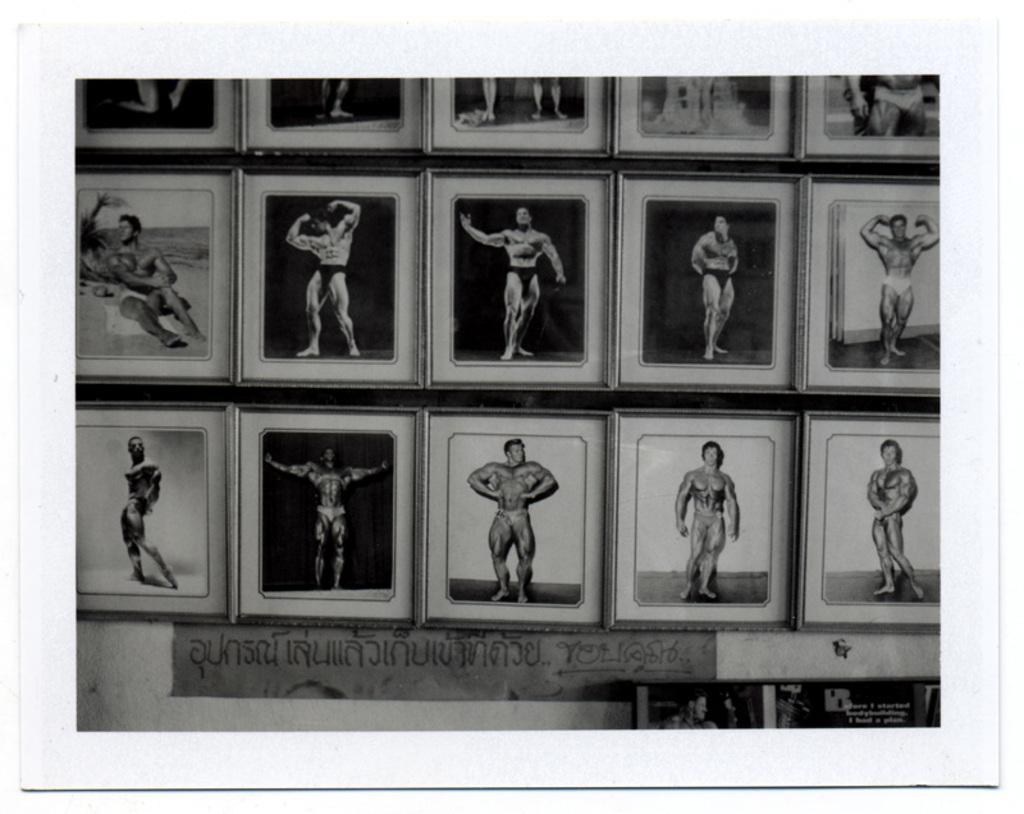Can you describe this image briefly? In this picture we can see frames and in these frames we can see a person in different positions. 